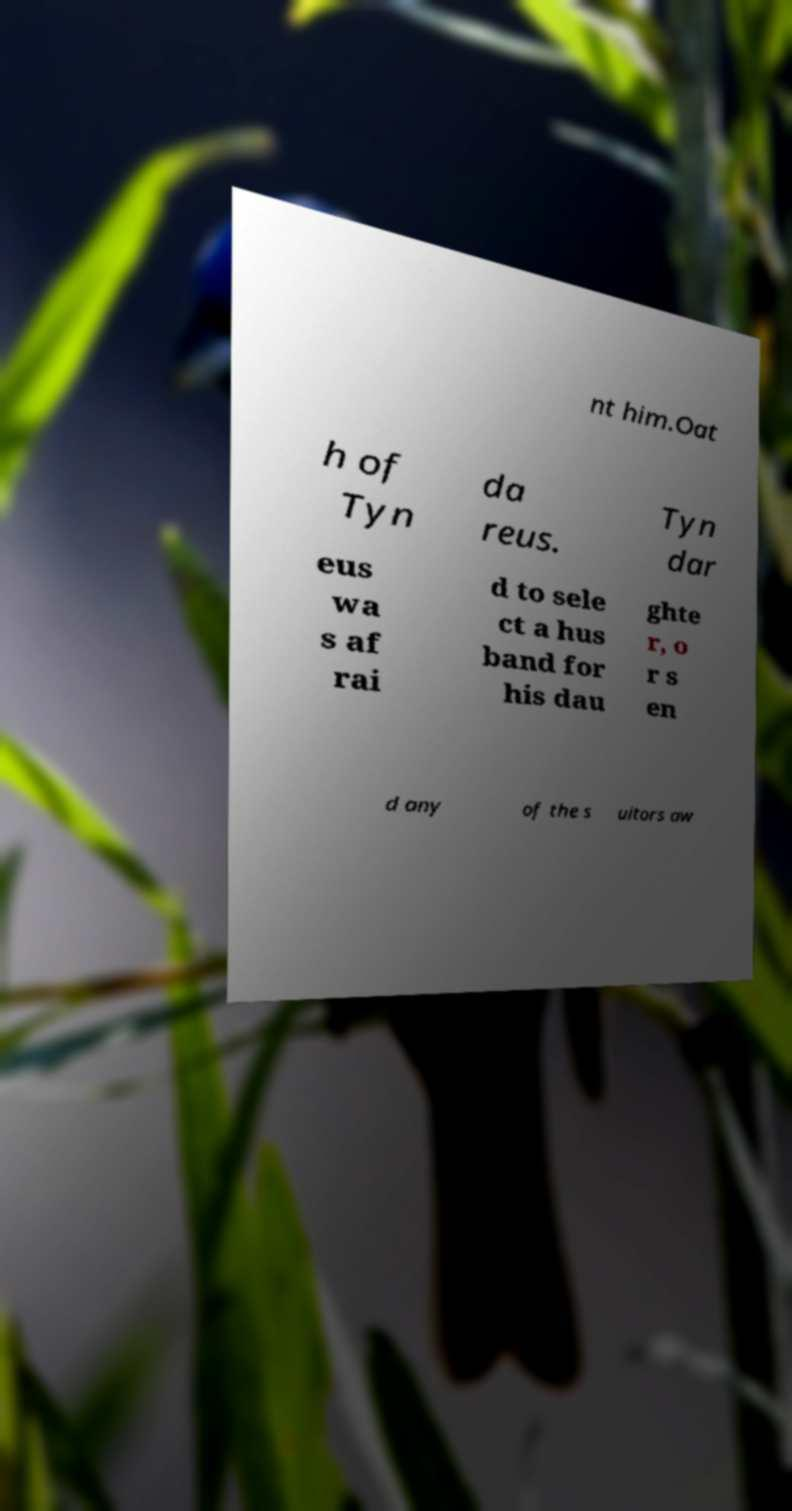Could you extract and type out the text from this image? nt him.Oat h of Tyn da reus. Tyn dar eus wa s af rai d to sele ct a hus band for his dau ghte r, o r s en d any of the s uitors aw 